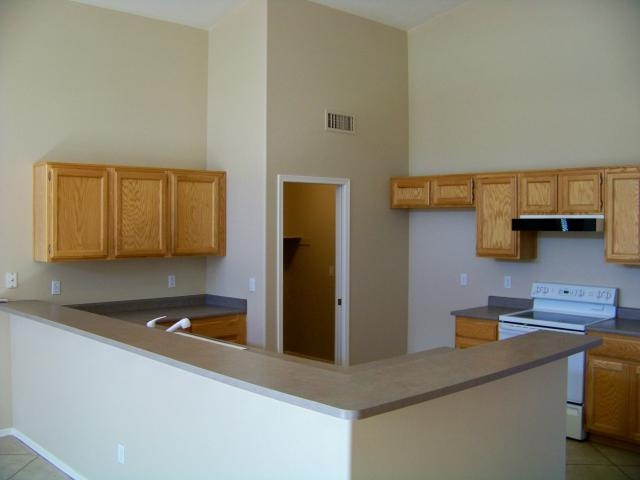Describe the objects in this image and their specific colors. I can see oven in gray and darkgray tones and sink in gray and darkgray tones in this image. 